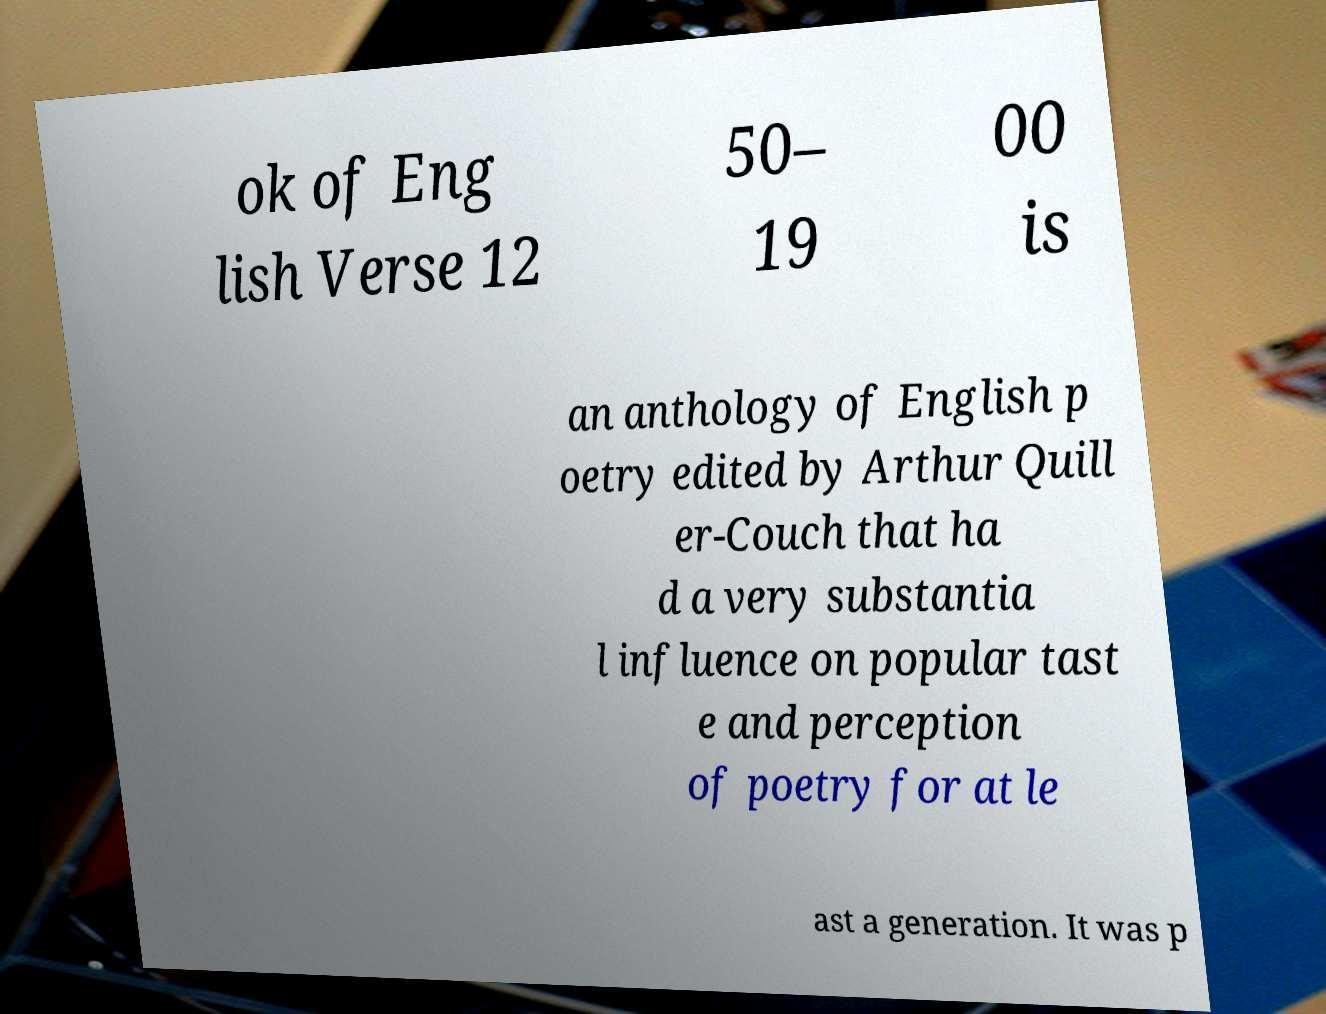Can you accurately transcribe the text from the provided image for me? ok of Eng lish Verse 12 50– 19 00 is an anthology of English p oetry edited by Arthur Quill er-Couch that ha d a very substantia l influence on popular tast e and perception of poetry for at le ast a generation. It was p 